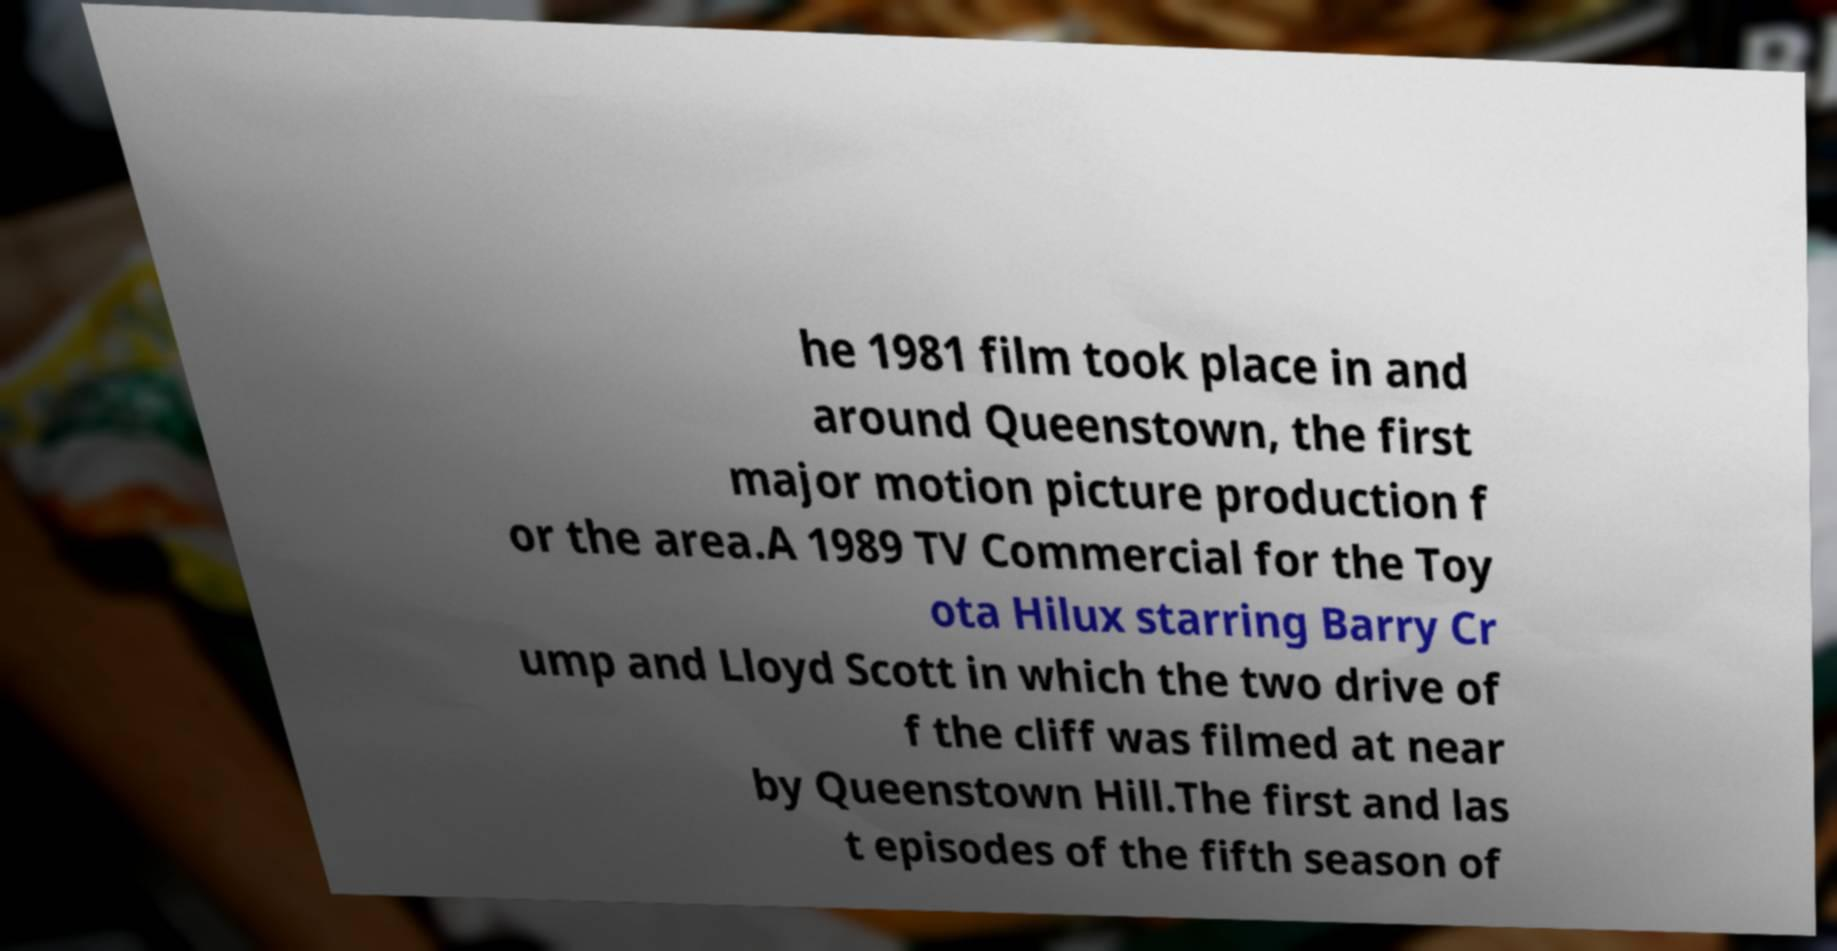What messages or text are displayed in this image? I need them in a readable, typed format. he 1981 film took place in and around Queenstown, the first major motion picture production f or the area.A 1989 TV Commercial for the Toy ota Hilux starring Barry Cr ump and Lloyd Scott in which the two drive of f the cliff was filmed at near by Queenstown Hill.The first and las t episodes of the fifth season of 